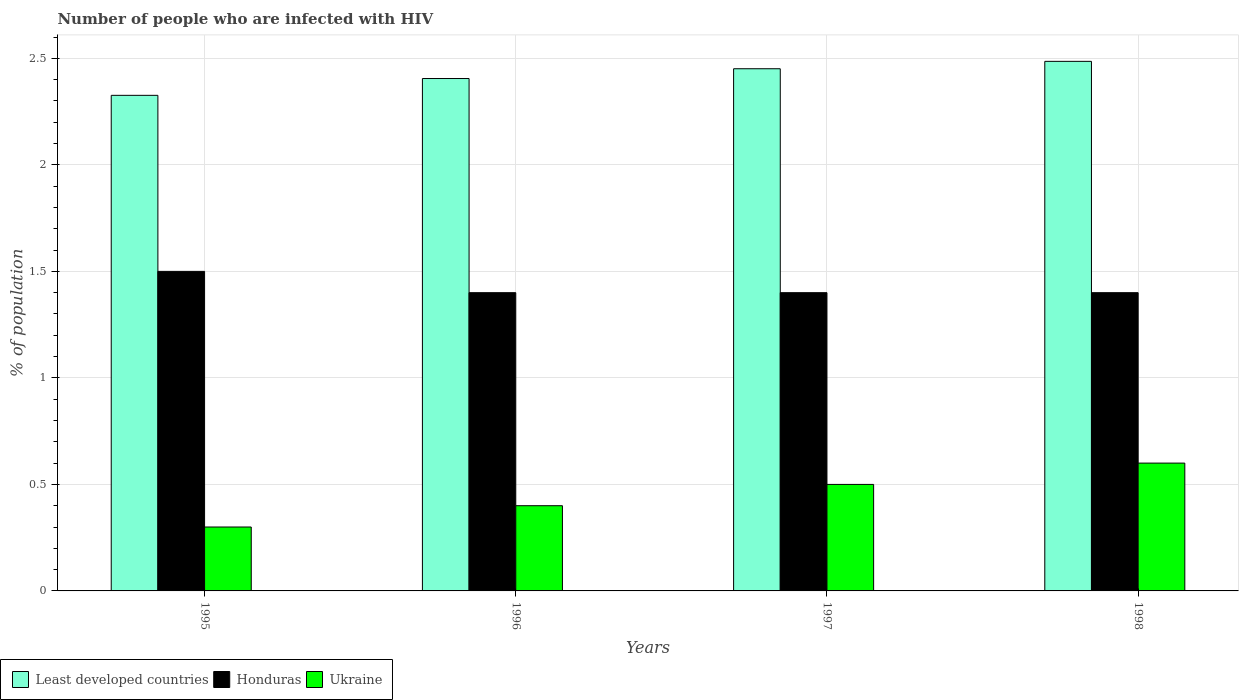How many groups of bars are there?
Provide a short and direct response. 4. Are the number of bars per tick equal to the number of legend labels?
Offer a very short reply. Yes. Are the number of bars on each tick of the X-axis equal?
Keep it short and to the point. Yes. How many bars are there on the 3rd tick from the left?
Offer a very short reply. 3. In how many cases, is the number of bars for a given year not equal to the number of legend labels?
Your answer should be very brief. 0. Across all years, what is the maximum percentage of HIV infected population in in Ukraine?
Your answer should be compact. 0.6. Across all years, what is the minimum percentage of HIV infected population in in Honduras?
Provide a succinct answer. 1.4. In which year was the percentage of HIV infected population in in Least developed countries maximum?
Ensure brevity in your answer.  1998. What is the total percentage of HIV infected population in in Ukraine in the graph?
Your response must be concise. 1.8. What is the difference between the percentage of HIV infected population in in Ukraine in 1997 and the percentage of HIV infected population in in Honduras in 1995?
Make the answer very short. -1. What is the average percentage of HIV infected population in in Least developed countries per year?
Ensure brevity in your answer.  2.42. In the year 1998, what is the difference between the percentage of HIV infected population in in Least developed countries and percentage of HIV infected population in in Ukraine?
Ensure brevity in your answer.  1.89. What is the ratio of the percentage of HIV infected population in in Ukraine in 1997 to that in 1998?
Ensure brevity in your answer.  0.83. Is the difference between the percentage of HIV infected population in in Least developed countries in 1995 and 1997 greater than the difference between the percentage of HIV infected population in in Ukraine in 1995 and 1997?
Your answer should be very brief. Yes. What is the difference between the highest and the second highest percentage of HIV infected population in in Ukraine?
Your answer should be very brief. 0.1. What is the difference between the highest and the lowest percentage of HIV infected population in in Least developed countries?
Provide a short and direct response. 0.16. What does the 2nd bar from the left in 1997 represents?
Ensure brevity in your answer.  Honduras. What does the 2nd bar from the right in 1998 represents?
Make the answer very short. Honduras. How many bars are there?
Offer a very short reply. 12. Are all the bars in the graph horizontal?
Offer a very short reply. No. How many years are there in the graph?
Your answer should be very brief. 4. What is the difference between two consecutive major ticks on the Y-axis?
Your answer should be compact. 0.5. Are the values on the major ticks of Y-axis written in scientific E-notation?
Make the answer very short. No. Does the graph contain grids?
Ensure brevity in your answer.  Yes. Where does the legend appear in the graph?
Your answer should be compact. Bottom left. How are the legend labels stacked?
Make the answer very short. Horizontal. What is the title of the graph?
Offer a terse response. Number of people who are infected with HIV. What is the label or title of the X-axis?
Offer a very short reply. Years. What is the label or title of the Y-axis?
Provide a short and direct response. % of population. What is the % of population in Least developed countries in 1995?
Offer a terse response. 2.33. What is the % of population of Honduras in 1995?
Provide a succinct answer. 1.5. What is the % of population of Least developed countries in 1996?
Provide a succinct answer. 2.41. What is the % of population of Ukraine in 1996?
Offer a very short reply. 0.4. What is the % of population in Least developed countries in 1997?
Make the answer very short. 2.45. What is the % of population in Honduras in 1997?
Make the answer very short. 1.4. What is the % of population of Least developed countries in 1998?
Your answer should be compact. 2.49. Across all years, what is the maximum % of population in Least developed countries?
Make the answer very short. 2.49. Across all years, what is the maximum % of population of Ukraine?
Provide a succinct answer. 0.6. Across all years, what is the minimum % of population of Least developed countries?
Keep it short and to the point. 2.33. Across all years, what is the minimum % of population of Ukraine?
Offer a terse response. 0.3. What is the total % of population in Least developed countries in the graph?
Your answer should be very brief. 9.67. What is the total % of population in Honduras in the graph?
Ensure brevity in your answer.  5.7. What is the difference between the % of population in Least developed countries in 1995 and that in 1996?
Offer a very short reply. -0.08. What is the difference between the % of population in Honduras in 1995 and that in 1996?
Offer a very short reply. 0.1. What is the difference between the % of population of Least developed countries in 1995 and that in 1997?
Keep it short and to the point. -0.12. What is the difference between the % of population in Least developed countries in 1995 and that in 1998?
Ensure brevity in your answer.  -0.16. What is the difference between the % of population in Least developed countries in 1996 and that in 1997?
Your response must be concise. -0.05. What is the difference between the % of population in Least developed countries in 1996 and that in 1998?
Your answer should be very brief. -0.08. What is the difference between the % of population of Ukraine in 1996 and that in 1998?
Keep it short and to the point. -0.2. What is the difference between the % of population in Least developed countries in 1997 and that in 1998?
Make the answer very short. -0.03. What is the difference between the % of population in Ukraine in 1997 and that in 1998?
Offer a very short reply. -0.1. What is the difference between the % of population in Least developed countries in 1995 and the % of population in Honduras in 1996?
Your answer should be compact. 0.93. What is the difference between the % of population of Least developed countries in 1995 and the % of population of Ukraine in 1996?
Your answer should be very brief. 1.93. What is the difference between the % of population of Honduras in 1995 and the % of population of Ukraine in 1996?
Make the answer very short. 1.1. What is the difference between the % of population in Least developed countries in 1995 and the % of population in Honduras in 1997?
Make the answer very short. 0.93. What is the difference between the % of population in Least developed countries in 1995 and the % of population in Ukraine in 1997?
Give a very brief answer. 1.83. What is the difference between the % of population in Honduras in 1995 and the % of population in Ukraine in 1997?
Give a very brief answer. 1. What is the difference between the % of population in Least developed countries in 1995 and the % of population in Honduras in 1998?
Give a very brief answer. 0.93. What is the difference between the % of population in Least developed countries in 1995 and the % of population in Ukraine in 1998?
Your answer should be very brief. 1.73. What is the difference between the % of population in Least developed countries in 1996 and the % of population in Ukraine in 1997?
Give a very brief answer. 1.91. What is the difference between the % of population in Honduras in 1996 and the % of population in Ukraine in 1997?
Make the answer very short. 0.9. What is the difference between the % of population in Least developed countries in 1996 and the % of population in Ukraine in 1998?
Provide a short and direct response. 1.81. What is the difference between the % of population in Honduras in 1996 and the % of population in Ukraine in 1998?
Offer a terse response. 0.8. What is the difference between the % of population in Least developed countries in 1997 and the % of population in Honduras in 1998?
Provide a succinct answer. 1.05. What is the difference between the % of population of Least developed countries in 1997 and the % of population of Ukraine in 1998?
Ensure brevity in your answer.  1.85. What is the average % of population of Least developed countries per year?
Your answer should be very brief. 2.42. What is the average % of population in Honduras per year?
Give a very brief answer. 1.43. What is the average % of population in Ukraine per year?
Offer a very short reply. 0.45. In the year 1995, what is the difference between the % of population of Least developed countries and % of population of Honduras?
Offer a very short reply. 0.83. In the year 1995, what is the difference between the % of population in Least developed countries and % of population in Ukraine?
Your answer should be very brief. 2.03. In the year 1995, what is the difference between the % of population of Honduras and % of population of Ukraine?
Give a very brief answer. 1.2. In the year 1996, what is the difference between the % of population in Least developed countries and % of population in Ukraine?
Give a very brief answer. 2.01. In the year 1996, what is the difference between the % of population in Honduras and % of population in Ukraine?
Your answer should be compact. 1. In the year 1997, what is the difference between the % of population in Least developed countries and % of population in Honduras?
Your answer should be very brief. 1.05. In the year 1997, what is the difference between the % of population in Least developed countries and % of population in Ukraine?
Your answer should be very brief. 1.95. In the year 1998, what is the difference between the % of population of Least developed countries and % of population of Honduras?
Your answer should be very brief. 1.09. In the year 1998, what is the difference between the % of population of Least developed countries and % of population of Ukraine?
Provide a short and direct response. 1.89. In the year 1998, what is the difference between the % of population in Honduras and % of population in Ukraine?
Give a very brief answer. 0.8. What is the ratio of the % of population of Least developed countries in 1995 to that in 1996?
Offer a terse response. 0.97. What is the ratio of the % of population in Honduras in 1995 to that in 1996?
Ensure brevity in your answer.  1.07. What is the ratio of the % of population of Ukraine in 1995 to that in 1996?
Make the answer very short. 0.75. What is the ratio of the % of population in Least developed countries in 1995 to that in 1997?
Provide a short and direct response. 0.95. What is the ratio of the % of population in Honduras in 1995 to that in 1997?
Give a very brief answer. 1.07. What is the ratio of the % of population in Least developed countries in 1995 to that in 1998?
Offer a very short reply. 0.94. What is the ratio of the % of population of Honduras in 1995 to that in 1998?
Make the answer very short. 1.07. What is the ratio of the % of population in Least developed countries in 1996 to that in 1997?
Offer a terse response. 0.98. What is the ratio of the % of population of Honduras in 1996 to that in 1997?
Provide a short and direct response. 1. What is the ratio of the % of population of Least developed countries in 1996 to that in 1998?
Provide a succinct answer. 0.97. What is the difference between the highest and the second highest % of population of Least developed countries?
Keep it short and to the point. 0.03. What is the difference between the highest and the lowest % of population in Least developed countries?
Your response must be concise. 0.16. What is the difference between the highest and the lowest % of population of Ukraine?
Keep it short and to the point. 0.3. 